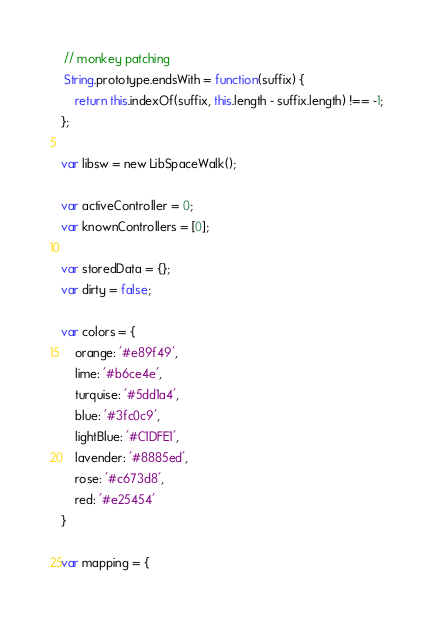<code> <loc_0><loc_0><loc_500><loc_500><_JavaScript_> // monkey patching
 String.prototype.endsWith = function(suffix) {
    return this.indexOf(suffix, this.length - suffix.length) !== -1;
};

var libsw = new LibSpaceWalk();

var activeController = 0;
var knownControllers = [0];

var storedData = {};
var dirty = false;

var colors = {
	orange: '#e89f49',
	lime: '#b6ce4e',
	turquise: '#5dd1a4',
	blue: '#3fc0c9',
	lightBlue: '#C1DFE1',
	lavender: '#8885ed',
	rose: '#c673d8',
	red: '#e25454'
}

var mapping = {</code> 